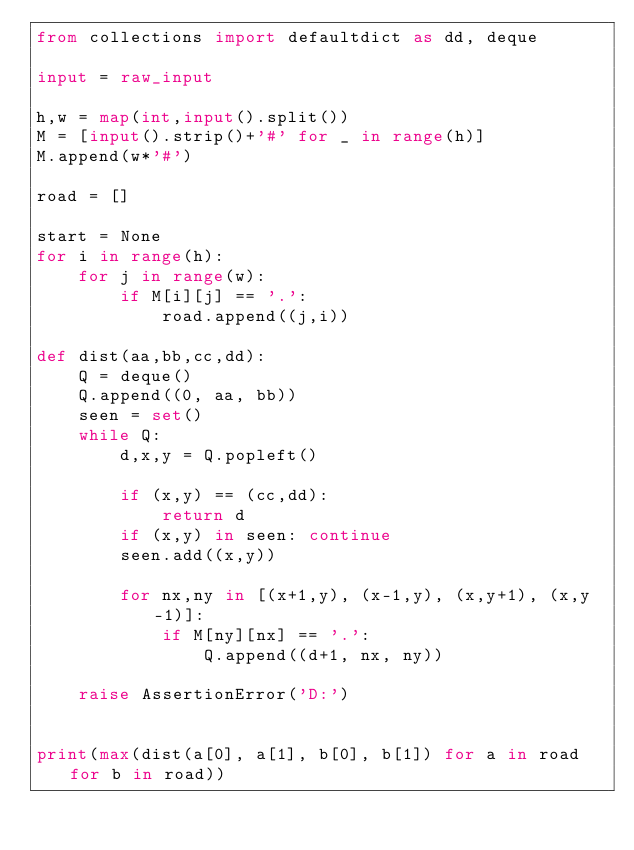<code> <loc_0><loc_0><loc_500><loc_500><_Python_>from collections import defaultdict as dd, deque

input = raw_input

h,w = map(int,input().split())
M = [input().strip()+'#' for _ in range(h)]
M.append(w*'#')

road = []

start = None
for i in range(h):
    for j in range(w):
        if M[i][j] == '.':
            road.append((j,i))

def dist(aa,bb,cc,dd):
    Q = deque()
    Q.append((0, aa, bb))
    seen = set()
    while Q:
        d,x,y = Q.popleft()

        if (x,y) == (cc,dd):
            return d
        if (x,y) in seen: continue
        seen.add((x,y))

        for nx,ny in [(x+1,y), (x-1,y), (x,y+1), (x,y-1)]:
            if M[ny][nx] == '.':
                Q.append((d+1, nx, ny))

    raise AssertionError('D:')


print(max(dist(a[0], a[1], b[0], b[1]) for a in road for b in road))
</code> 